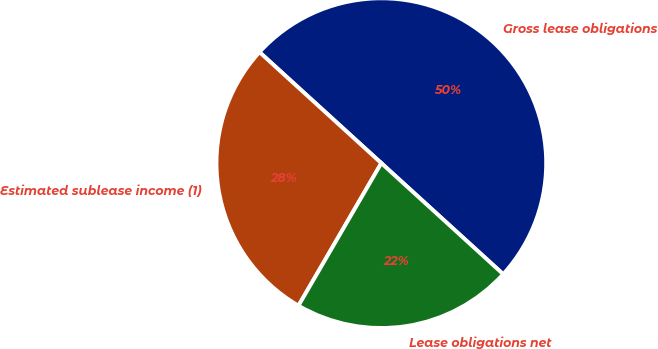Convert chart. <chart><loc_0><loc_0><loc_500><loc_500><pie_chart><fcel>Gross lease obligations<fcel>Estimated sublease income (1)<fcel>Lease obligations net<nl><fcel>50.0%<fcel>28.38%<fcel>21.62%<nl></chart> 